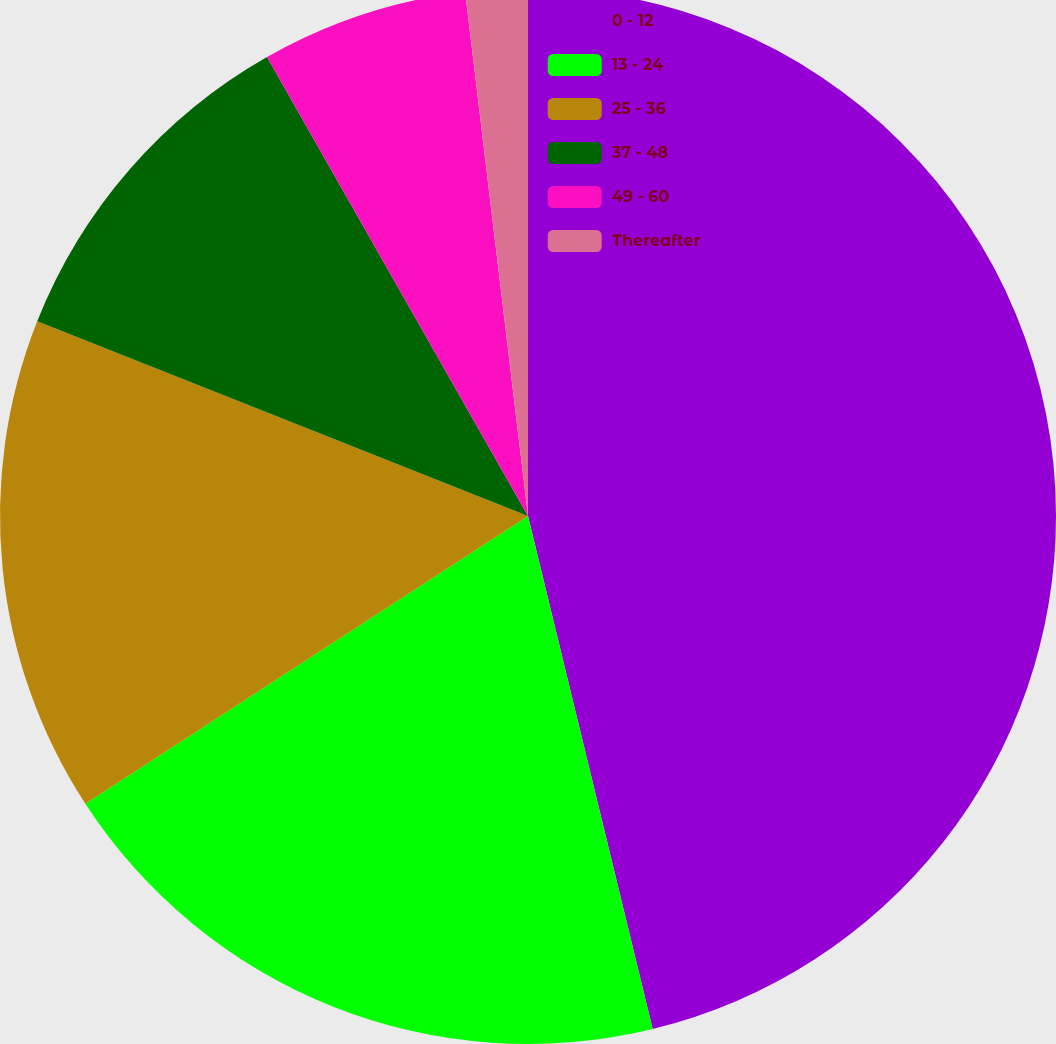Convert chart. <chart><loc_0><loc_0><loc_500><loc_500><pie_chart><fcel>0 - 12<fcel>13 - 24<fcel>25 - 36<fcel>37 - 48<fcel>49 - 60<fcel>Thereafter<nl><fcel>46.21%<fcel>19.62%<fcel>15.19%<fcel>10.76%<fcel>6.33%<fcel>1.9%<nl></chart> 